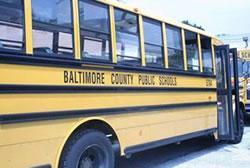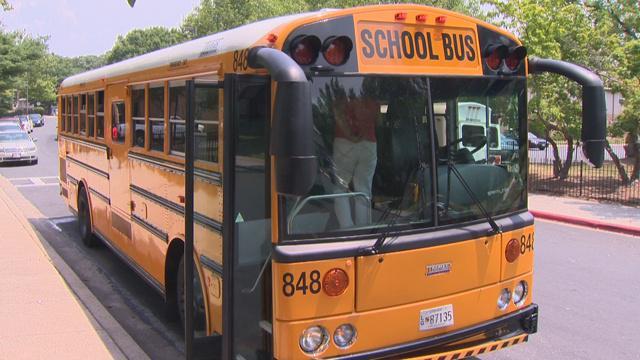The first image is the image on the left, the second image is the image on the right. Analyze the images presented: Is the assertion "In at least one of the images, a school bus has plowed into a commuter bus." valid? Answer yes or no. No. The first image is the image on the left, the second image is the image on the right. Given the left and right images, does the statement "Firefighters dressed in their gear and people wearing yellow safety jackets are working at the scene of a bus accident in at least one of the images." hold true? Answer yes or no. No. 